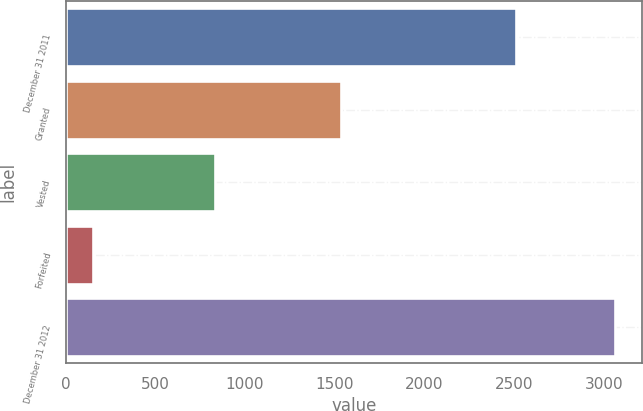Convert chart. <chart><loc_0><loc_0><loc_500><loc_500><bar_chart><fcel>December 31 2011<fcel>Granted<fcel>Vested<fcel>Forfeited<fcel>December 31 2012<nl><fcel>2512<fcel>1534<fcel>831<fcel>154<fcel>3061<nl></chart> 